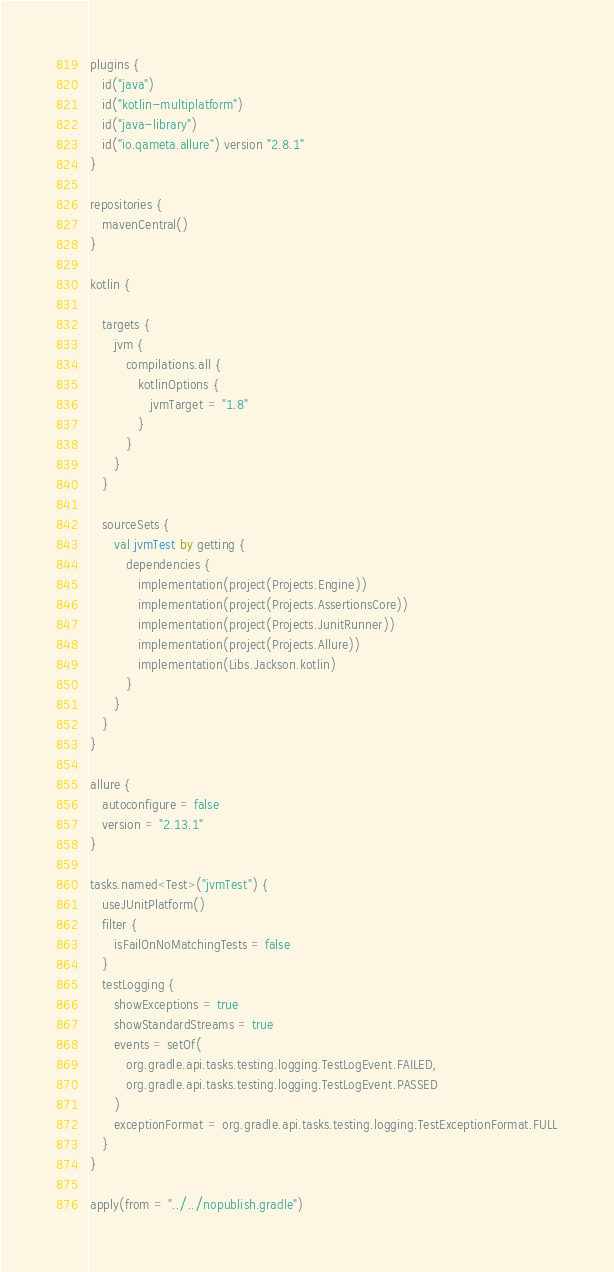Convert code to text. <code><loc_0><loc_0><loc_500><loc_500><_Kotlin_>plugins {
   id("java")
   id("kotlin-multiplatform")
   id("java-library")
   id("io.qameta.allure") version "2.8.1"
}

repositories {
   mavenCentral()
}

kotlin {

   targets {
      jvm {
         compilations.all {
            kotlinOptions {
               jvmTarget = "1.8"
            }
         }
      }
   }

   sourceSets {
      val jvmTest by getting {
         dependencies {
            implementation(project(Projects.Engine))
            implementation(project(Projects.AssertionsCore))
            implementation(project(Projects.JunitRunner))
            implementation(project(Projects.Allure))
            implementation(Libs.Jackson.kotlin)
         }
      }
   }
}

allure {
   autoconfigure = false
   version = "2.13.1"
}

tasks.named<Test>("jvmTest") {
   useJUnitPlatform()
   filter {
      isFailOnNoMatchingTests = false
   }
   testLogging {
      showExceptions = true
      showStandardStreams = true
      events = setOf(
         org.gradle.api.tasks.testing.logging.TestLogEvent.FAILED,
         org.gradle.api.tasks.testing.logging.TestLogEvent.PASSED
      )
      exceptionFormat = org.gradle.api.tasks.testing.logging.TestExceptionFormat.FULL
   }
}

apply(from = "../../nopublish.gradle")
</code> 